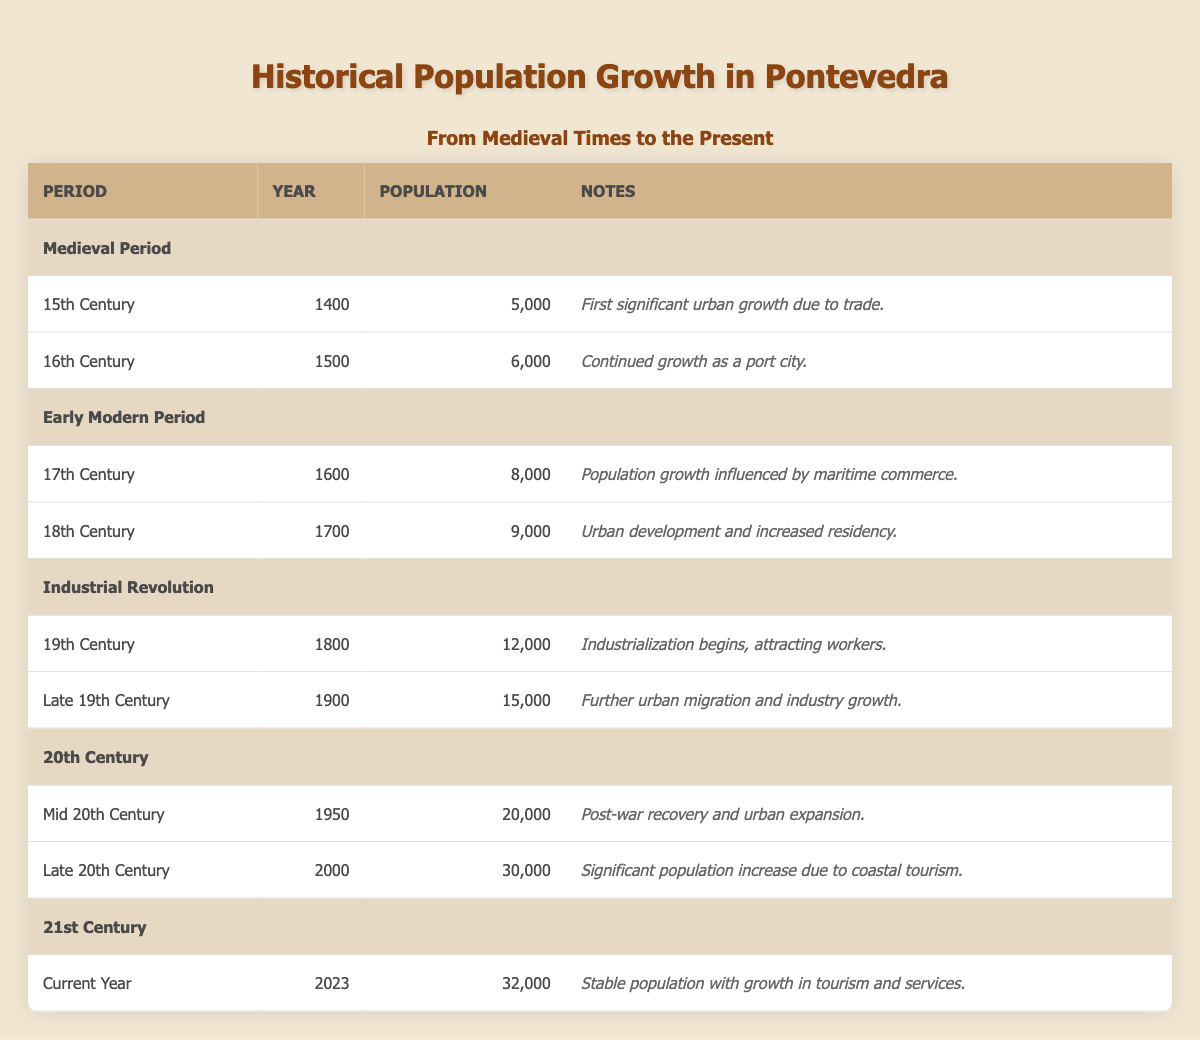What was the population of Pontevedra in the year 1500? The table lists the population of Pontevedra for the year 1500 as 6,000.
Answer: 6,000 What significant change occurred in Pontevedra's population between 1700 and 1800? The population increased from 9,000 in 1700 to 12,000 in 1800, which is a growth of 3,000 people.
Answer: An increase of 3,000 people Is it true that the population of Pontevedra decreased from 1900 to 1950? In 1900, the population was 15,000 and by 1950, it had grown to 20,000, indicating an increase rather than a decrease.
Answer: No What was the total population growth from the year 1400 to 2023? The total population in 1400 was 5,000 and in 2023 it is 32,000. The growth can be calculated as 32,000 - 5,000 = 27,000.
Answer: 27,000 Which century saw the highest recorded population in Pontevedra? The highest recorded population in the table is 32,000 in the 21st century (2023).
Answer: 21st Century What was the average population between 1800 and 2000? The populations for those years were 12,000 in 1800, 15,000 in 1900, and 30,000 in 2000. The average can be calculated as (12,000 + 15,000 + 30,000) / 3 = 57,000 / 3 = 19,000.
Answer: 19,000 What was the primary influence on Pontevedra’s population growth in the 17th century? The 17th-century growth was significantly influenced by maritime commerce, as stated in the table.
Answer: Maritime commerce How much did the population of Pontevedra grow from 2000 to 2023? The population grew from 30,000 in 2000 to 32,000 in 2023, which is an increase of 2,000.
Answer: An increase of 2,000 How many centuries saw a population greater than 10,000? The table shows that from the 19th century onward, populations exceeded 10,000, specifically in the 19th (12,000) and 20th centuries (20,000 and 30,000). Thus, three centuries had populations over 10,000.
Answer: Three centuries 